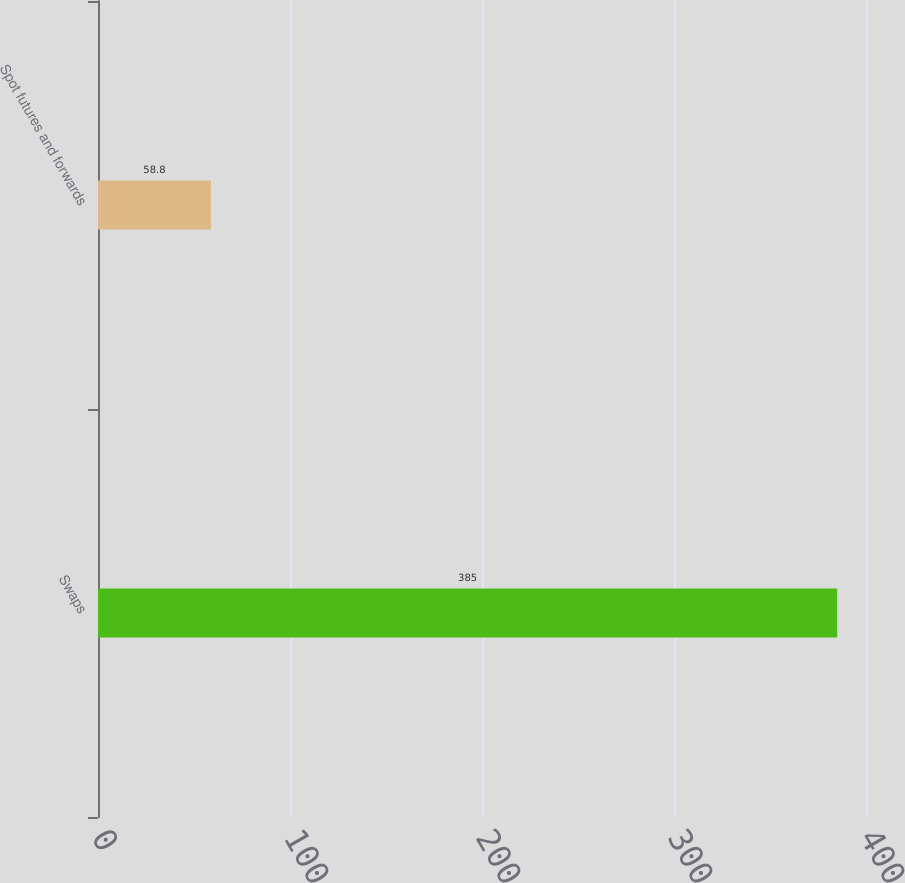Convert chart to OTSL. <chart><loc_0><loc_0><loc_500><loc_500><bar_chart><fcel>Swaps<fcel>Spot futures and forwards<nl><fcel>385<fcel>58.8<nl></chart> 